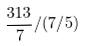<formula> <loc_0><loc_0><loc_500><loc_500>\frac { 3 1 3 } { 7 } / ( 7 / 5 )</formula> 